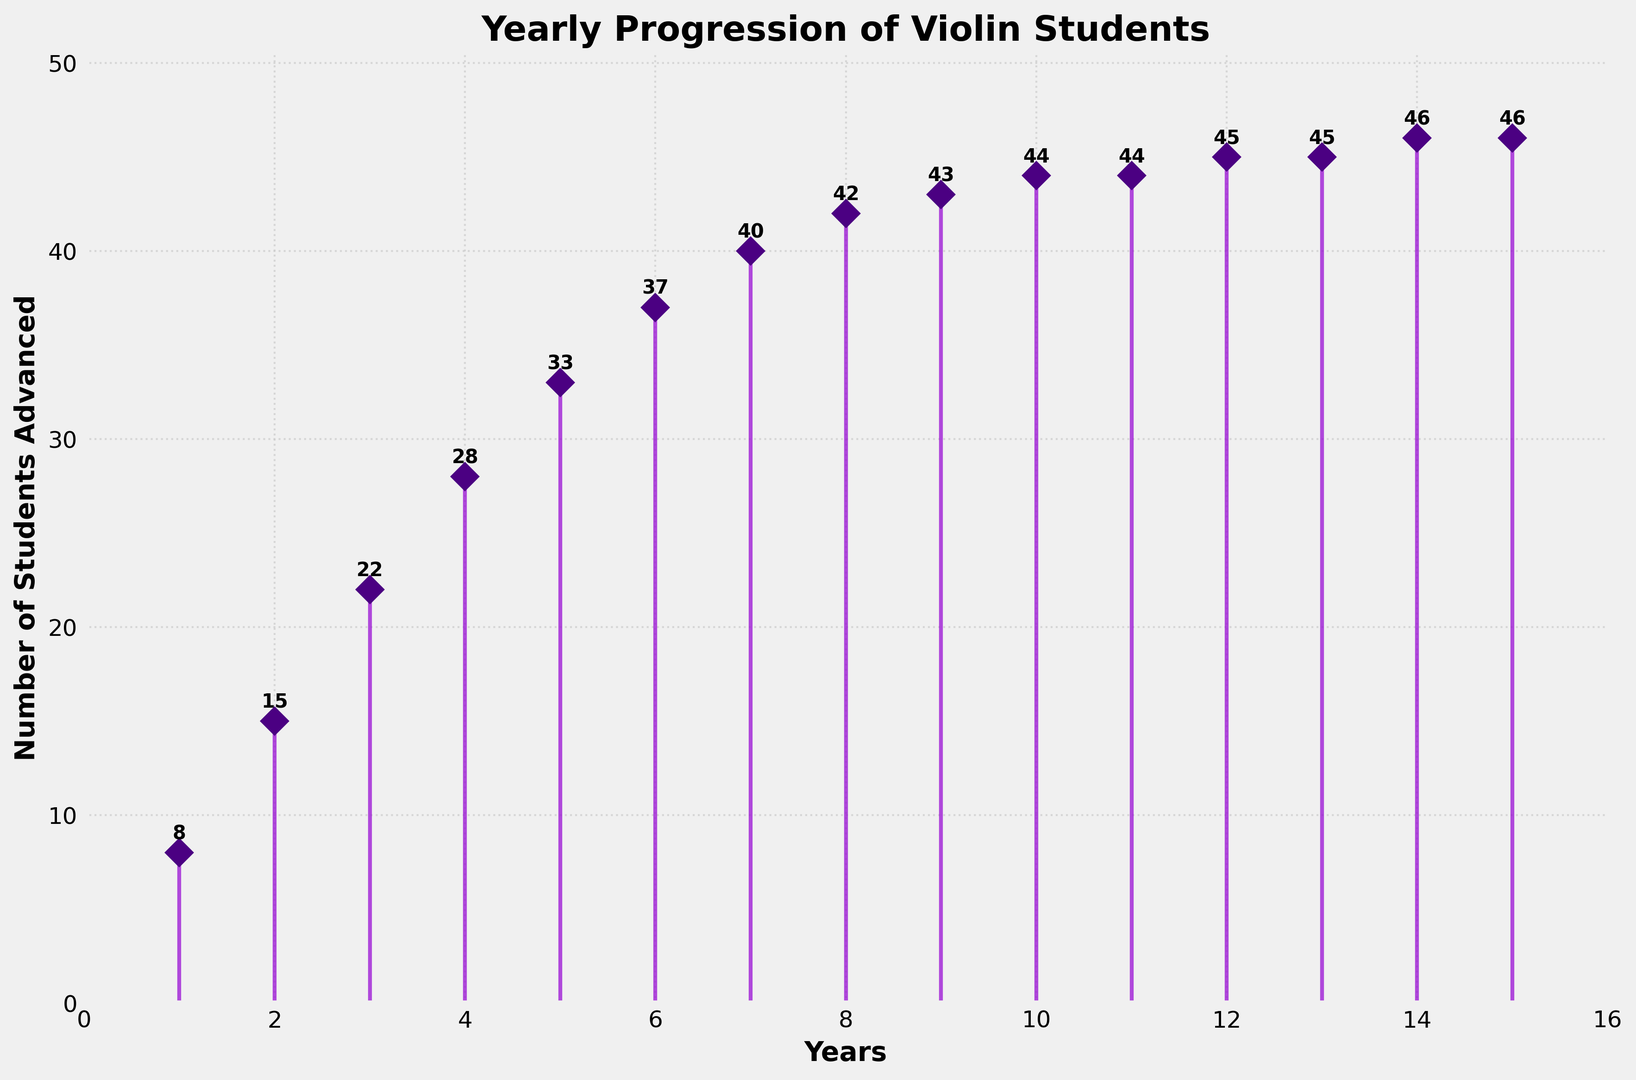What is the overall trend in the number of students advancing through violin grades over the 15 years? The overall trend shows a steady increase. The number of students advancing rises from 8 in year 1 to 46 in year 15, with a slight leveling off after year 10.
Answer: Steady increase How many students advanced in the 5th year? Looking at the figure, the number of students advanced in the 5th year is labeled beside the stem for year 5.
Answer: 33 What is the difference in the number of students advanced between the 8th and 10th years? In the 8th year, 42 students advanced, and in the 10th year, 44 students advanced. The difference is 44 - 42.
Answer: 2 How do the number of students advanced in the 2nd year compare to the 9th year? In the 2nd year, 15 students advanced, and in the 9th year, 43 students advanced. Comparing these two, 43 is greater than 15.
Answer: 43 > 15 Which year saw the highest number of students advancing, and what is that number? The highest number of students advanced is found at the top-most point on the plot line, which is 46 in years 14 and 15.
Answer: Year 14 and 15, 46 students Identify the year with the least number of students advancing. The least number of students advancing is at the bottom-most point on the plot line, which is 8 in the 1st year.
Answer: Year 1 How many years did it take for the number of students advancing to reach at least 40? Looking at the figure, the number of students reaches 40 by year 7.
Answer: 7 years What's the average number of students advancing over the 15 years? Summing the numbers of students advancing each year (8 + 15 + 22 + 28 + 33 + 37 + 40 + 42 + 43 + 44 + 44 + 45 + 45 + 46 + 46) gives 538. Dividing this sum by 15 years gives an average of 35.87 students.
Answer: 35.87 From which year to which year does the number of students advancing increase the most? The visual text labels and marker points on the stems between year 1 and year 2 show an increase from 8 to 15, which is a jump of 7 students. This is the largest yearly increase seen in the plot.
Answer: Year 1 to Year 2 